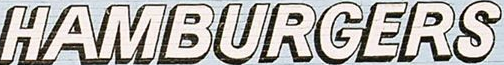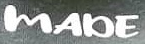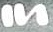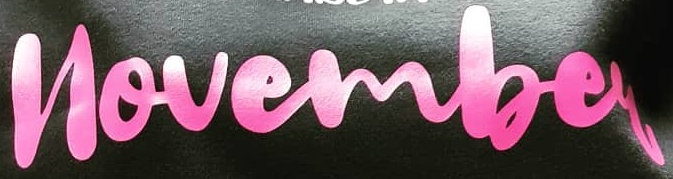Transcribe the words shown in these images in order, separated by a semicolon. HAMBURGERS; MADE; In; novembey 